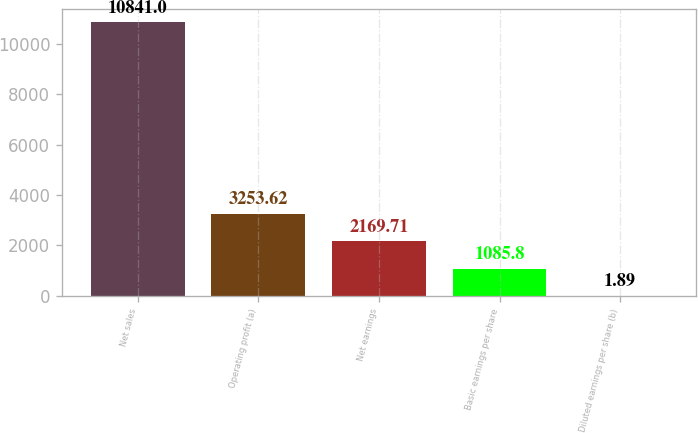<chart> <loc_0><loc_0><loc_500><loc_500><bar_chart><fcel>Net sales<fcel>Operating profit (a)<fcel>Net earnings<fcel>Basic earnings per share<fcel>Diluted earnings per share (b)<nl><fcel>10841<fcel>3253.62<fcel>2169.71<fcel>1085.8<fcel>1.89<nl></chart> 